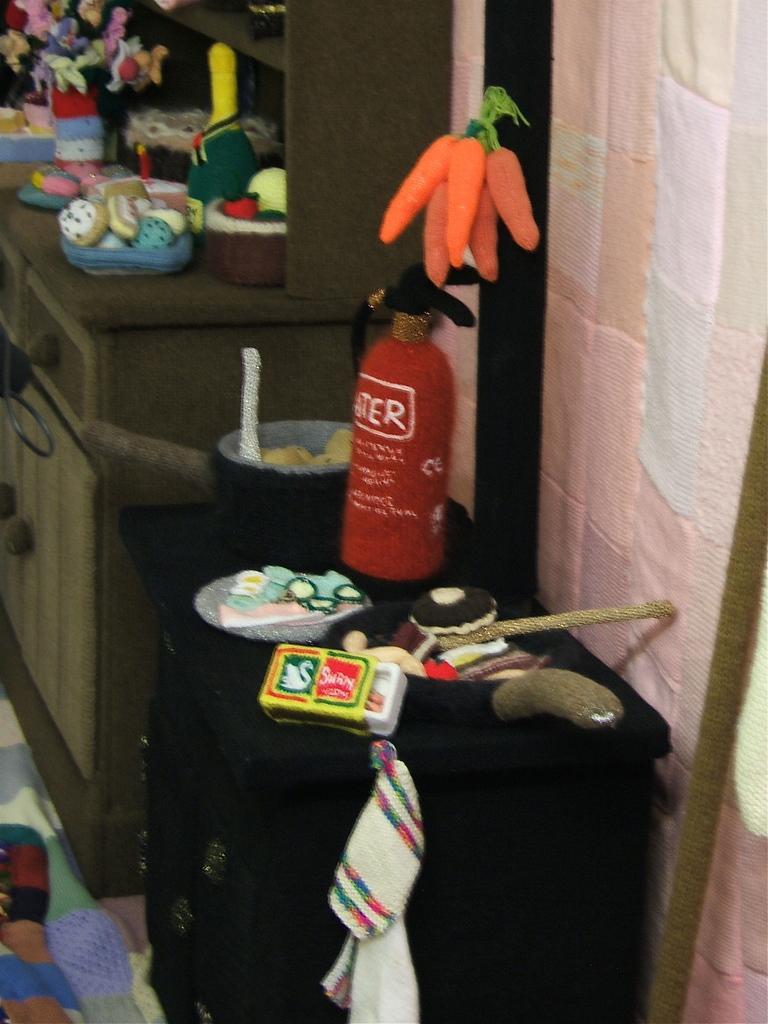How would you summarize this image in a sentence or two? In the image in center there is a table on the table there are few objects. Here the fire engine and there is a wall where carrots were tied up,back of the table there is another table it is also considered with the few objects on it. 